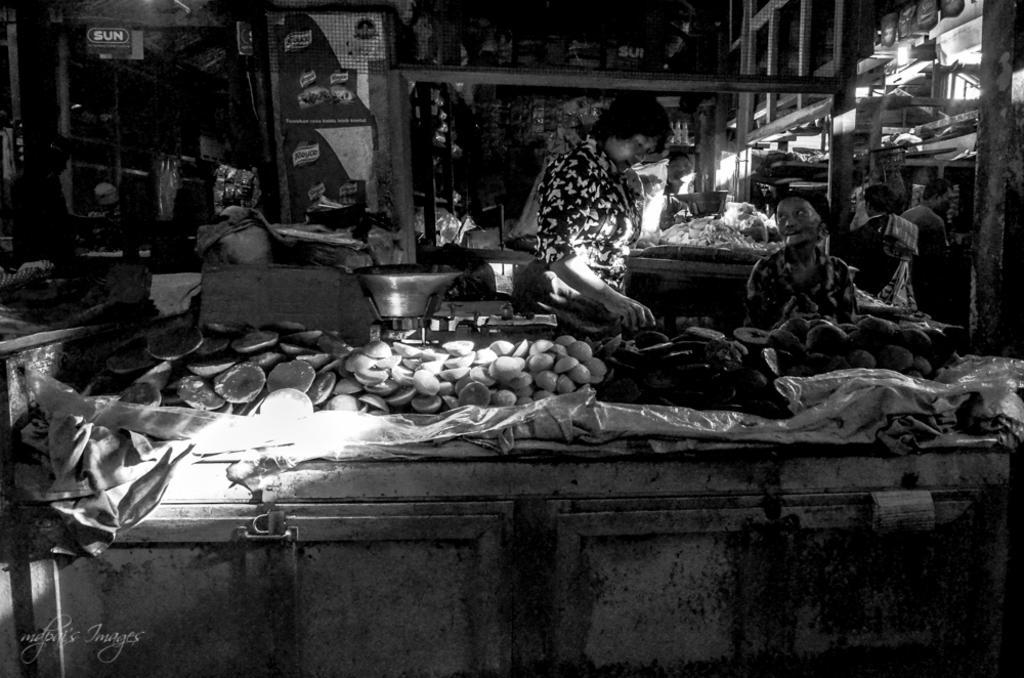Can you describe this image briefly? This is a black and white image. We can see the view of a vegetable market. There are a few people. We can see some tables covered with covers and some objects are placed on them. There are a few weighing machines. We can see some boards with text. We can also see some shelves with objects. We can see some poles and a light. 